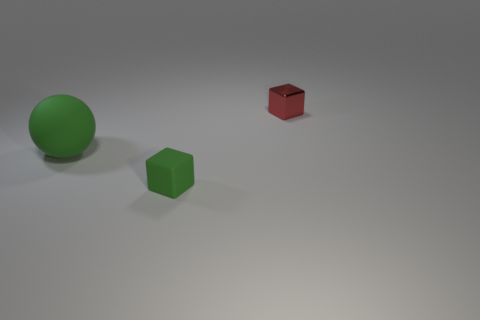Add 1 small shiny objects. How many objects exist? 4 Subtract all blocks. How many objects are left? 1 Add 1 green rubber blocks. How many green rubber blocks are left? 2 Add 2 big green things. How many big green things exist? 3 Subtract 0 gray balls. How many objects are left? 3 Subtract all green matte cubes. Subtract all tiny rubber objects. How many objects are left? 1 